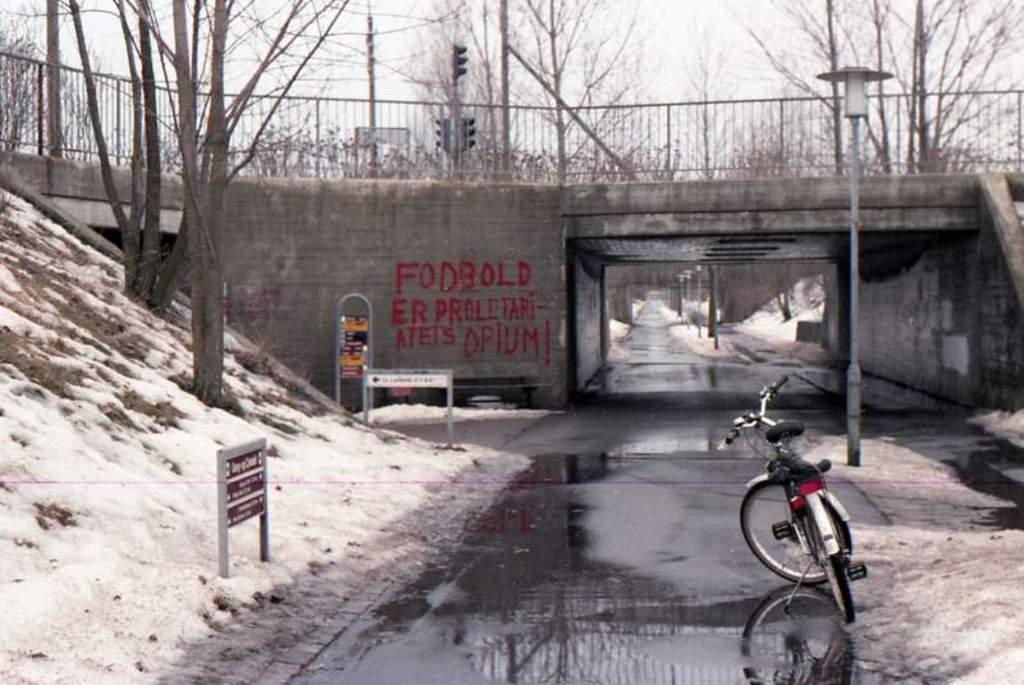How would you summarize this image in a sentence or two? In the picture we can see a road which is wet with some water on it and a bicycle is parked on it and besides on the either sides we can see a snow path with some trees on it and in the background, we can see a bridge on it we can see a railing and behind it we can see some poles, trees and traffic lights and sky. 